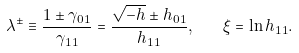<formula> <loc_0><loc_0><loc_500><loc_500>\lambda ^ { \pm } \equiv \frac { 1 \pm \gamma _ { 0 1 } } { \gamma _ { 1 1 } } = \frac { \sqrt { - h } \pm h _ { 0 1 } } { h _ { 1 1 } } , \quad \xi = \ln h _ { 1 1 } .</formula> 